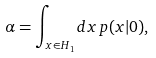Convert formula to latex. <formula><loc_0><loc_0><loc_500><loc_500>\alpha = \int _ { x \in H _ { 1 } } d x \, p ( x | 0 ) ,</formula> 